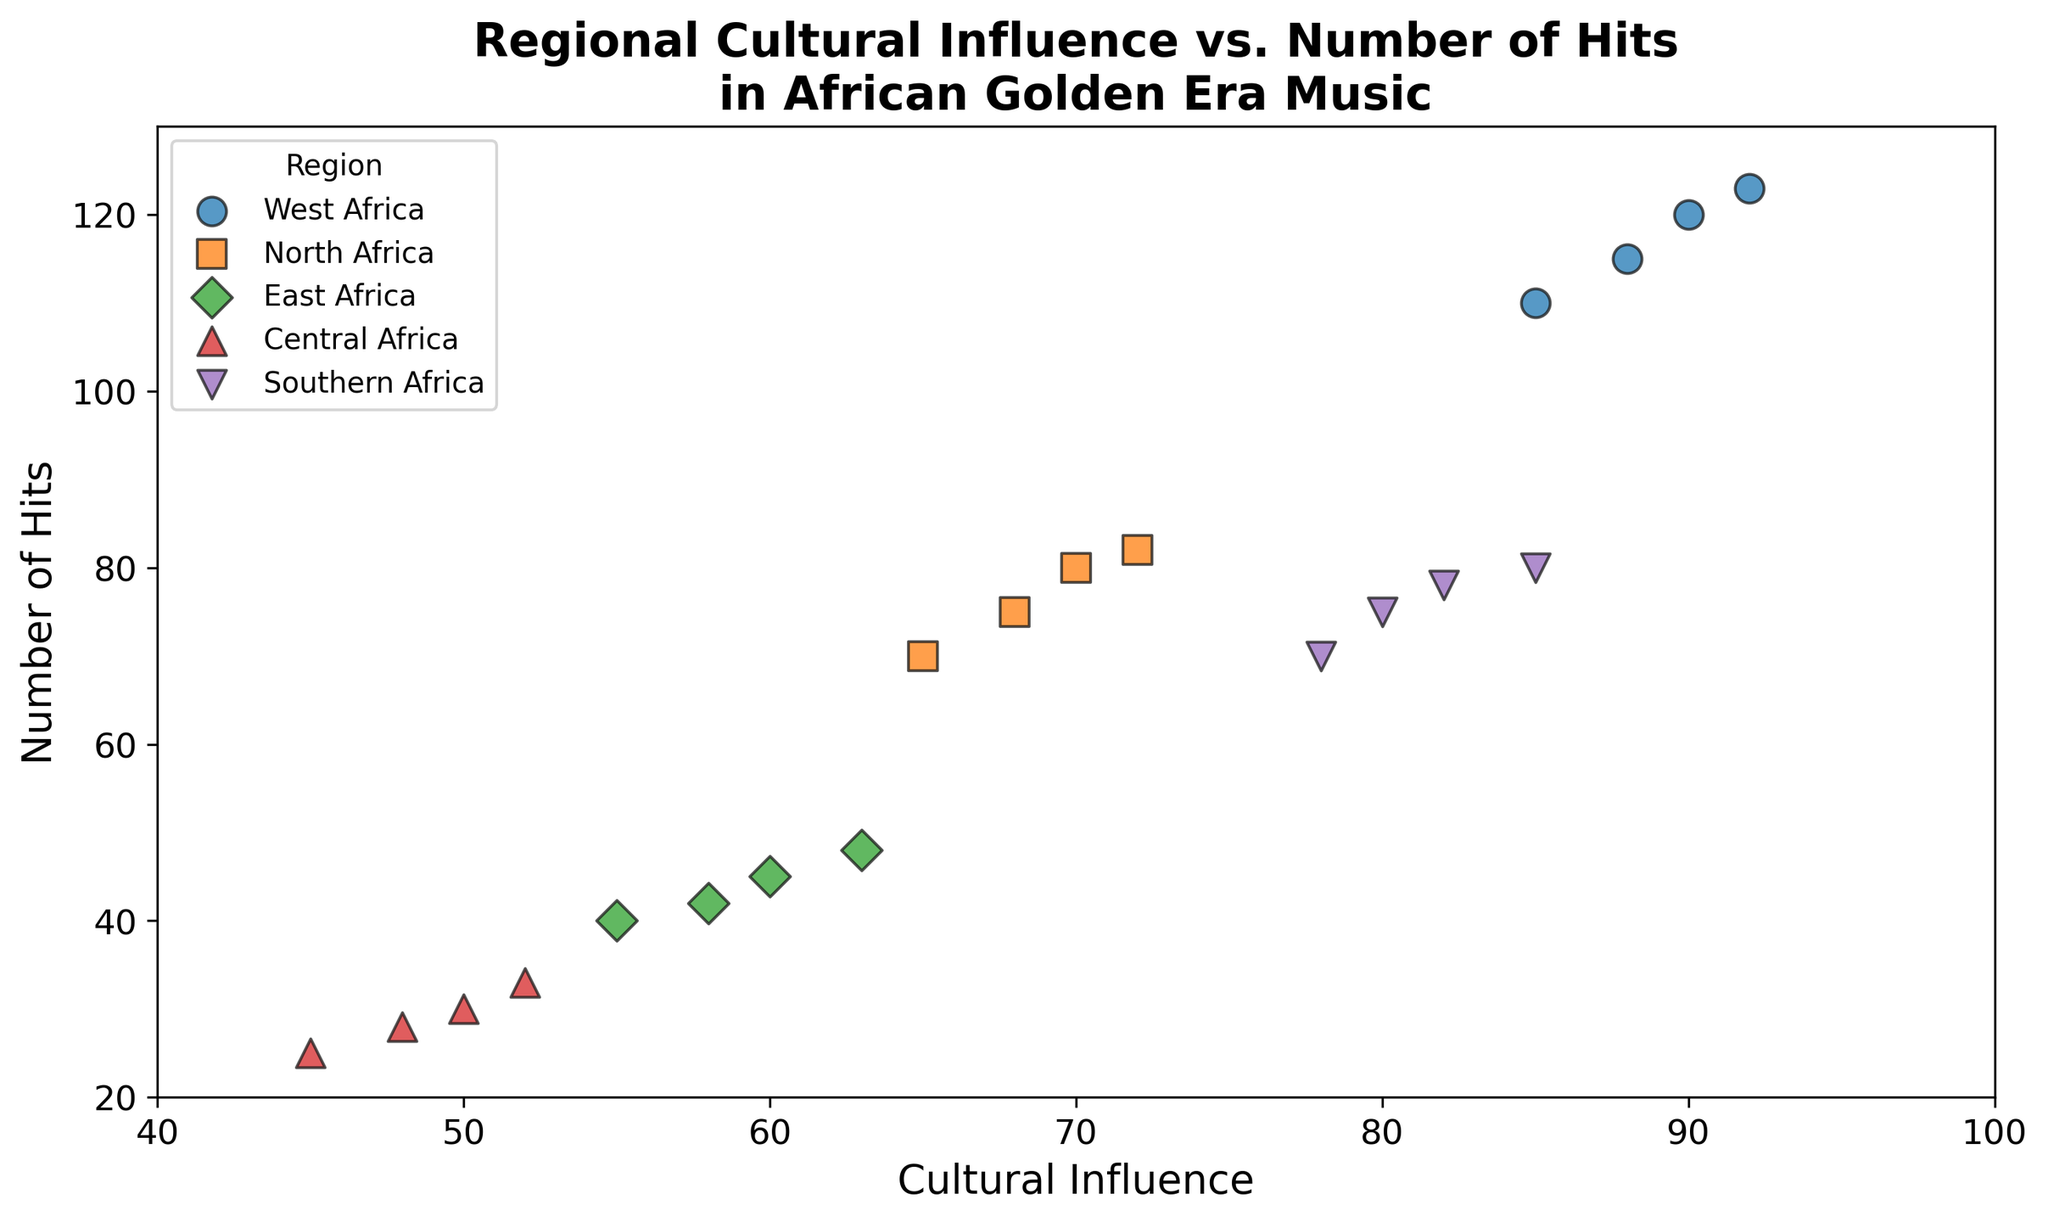Which region has the highest number of hits with the highest cultural influence? By looking at the plot, West Africa has the highest cultural influence of 92 and the highest number of hits of 123 among all regions.
Answer: West Africa How does Southern Africa's number of hits compare between points with 78 and 85 cultural influence? Southern Africa has hits of 75 when cultural influence is 78 and hits of 80 when cultural influence is 85. Comparing these shows that the number of hits increased from 75 to 80 as the cultural influence increased from 78 to 85.
Answer: 75 to 80, increased Which region shows the least variation in cultural influence and number of hits? By observing the scatter plot, each region shows variation, but Central Africa has the smallest span in both cultural influence (45 to 52) and number of hits (25 to 33).
Answer: Central Africa What is the average number of hits for East Africa’s data points? East Africa's data points have hits of 45, 40, 42, and 48. Average = (45 + 40 + 42 + 48) / 4 = 43.75
Answer: 43.75 Between West Africa and North Africa, which region has a data point with a higher number of hits where cultural influence is around 90? West Africa has a data point with a cultural influence of 90 and 120 hits. North Africa does not have a point with a cultural influence around 90. Thus, West Africa has a higher number of hits.
Answer: West Africa Which region has the most data points closer to the upper-right corner of the plot? Observing the plot, West Africa has more data points near the upper-right corner with higher cultural influence and number of hits.
Answer: West Africa What is the difference in the number of hits between the highest values for West Africa and Central Africa? The highest number of hits for West Africa is 123, and for Central Africa is 33. The difference is 123 - 33 = 90.
Answer: 90 What color represents North Africa and how many data points does it have on the plot? North Africa is represented by the color orange and has five data points on the plot.
Answer: Orange, five For regions with cultural influence of at least 80, which one has the lowest number of hits recorded? By observing regions with cultural influence of at least 80, Southern Africa has the lowest number of hits with a data point of 75 hits and an influence of 80.
Answer: Southern Africa What’s the range of cultural influences observed for Southern Africa in the plot? Southern Africa has cultural influences of 78, 80, 82, 85. The range is 85 - 78 = 7.
Answer: 7 